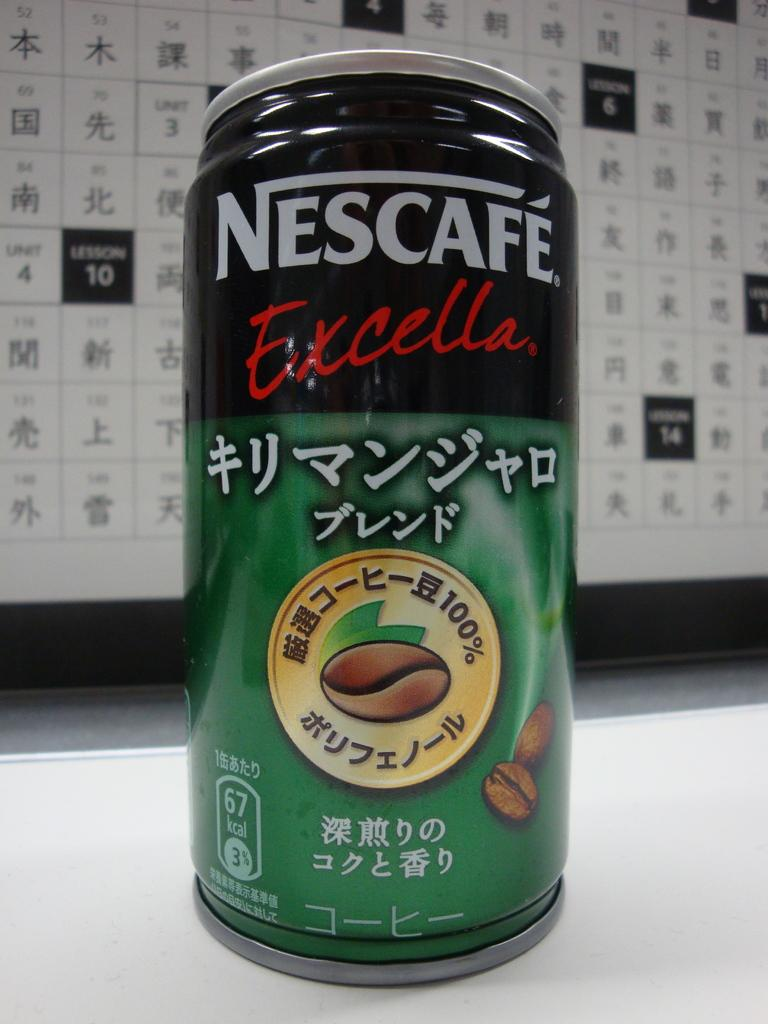<image>
Give a short and clear explanation of the subsequent image. A can of beverage that is made by Nescafe. 